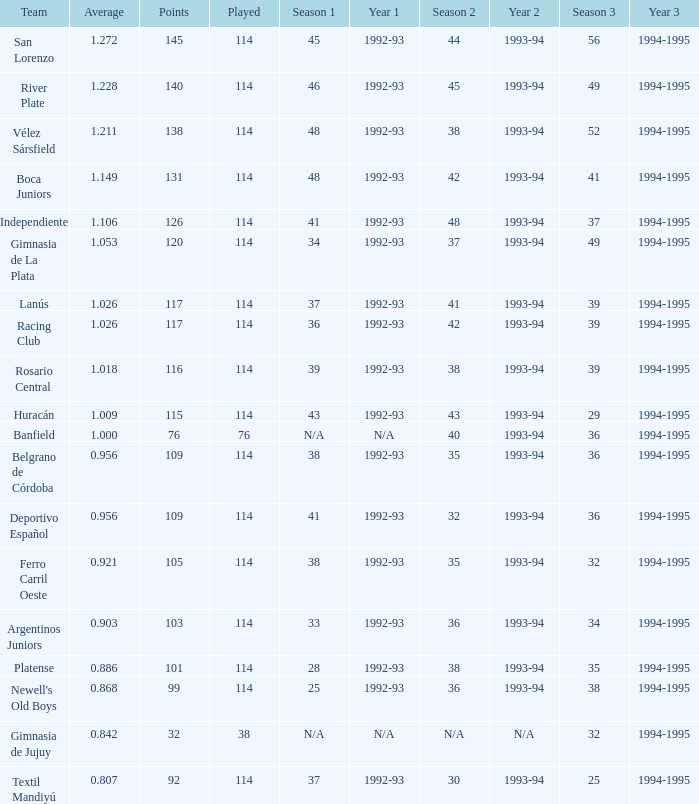Name the total number of 1992-93 for 115 points 1.0. 